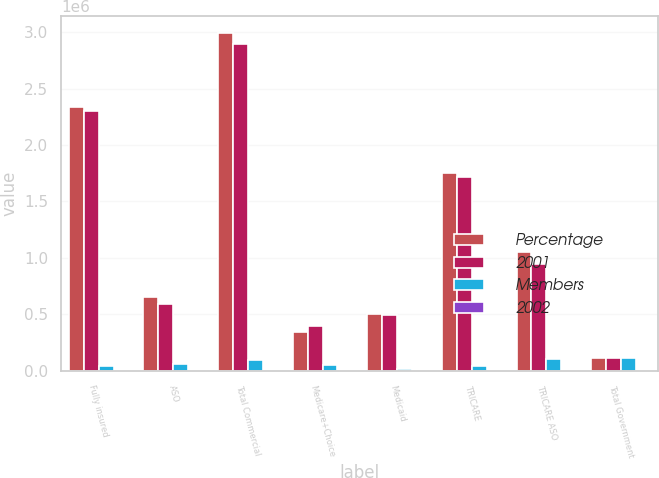<chart> <loc_0><loc_0><loc_500><loc_500><stacked_bar_chart><ecel><fcel>Fully insured<fcel>ASO<fcel>Total Commercial<fcel>Medicare+Choice<fcel>Medicaid<fcel>TRICARE<fcel>TRICARE ASO<fcel>Total Government<nl><fcel>Percentage<fcel>2.3403e+06<fcel>652200<fcel>2.9925e+06<fcel>344100<fcel>506000<fcel>1.7558e+06<fcel>1.0487e+06<fcel>109300<nl><fcel>2001<fcel>2.3013e+06<fcel>592500<fcel>2.8938e+06<fcel>393900<fcel>490800<fcel>1.7146e+06<fcel>942700<fcel>109300<nl><fcel>Members<fcel>39000<fcel>59700<fcel>98700<fcel>49800<fcel>15200<fcel>41200<fcel>106000<fcel>112600<nl><fcel>2002<fcel>1.7<fcel>10.1<fcel>3.4<fcel>12.6<fcel>3.1<fcel>2.4<fcel>11.2<fcel>3.2<nl></chart> 